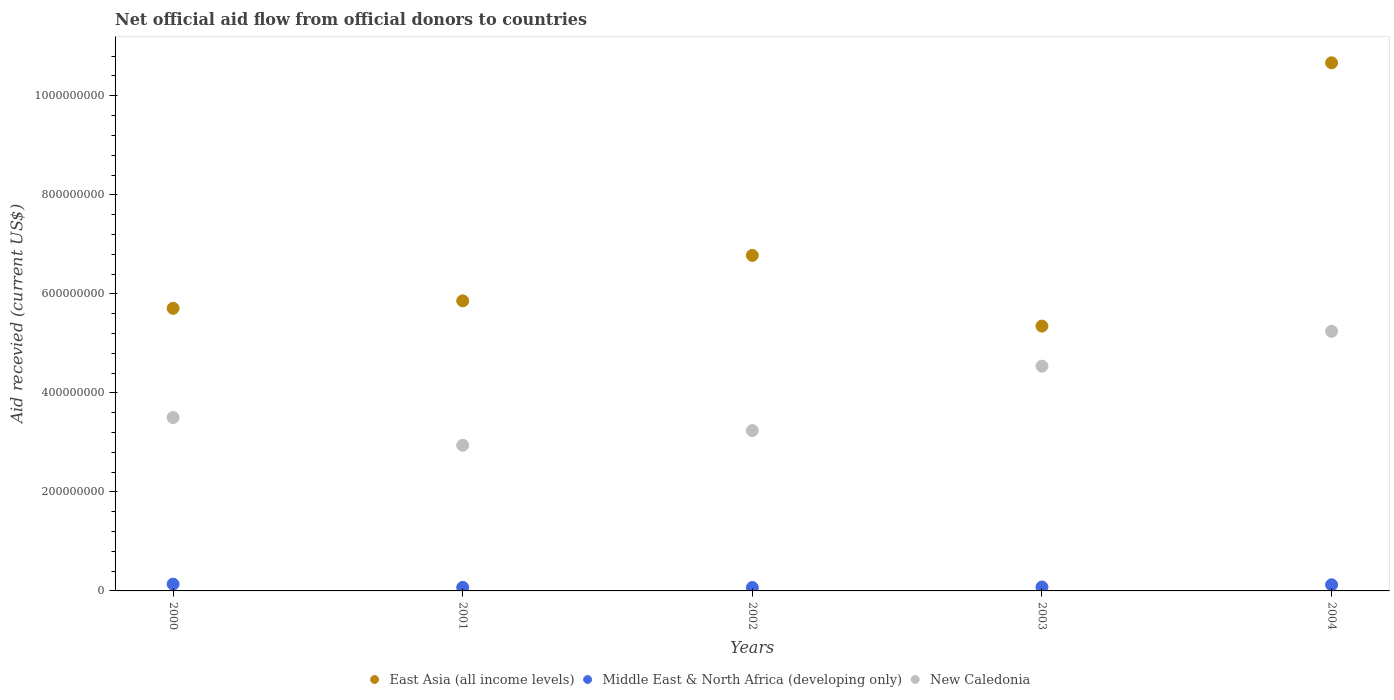How many different coloured dotlines are there?
Offer a terse response. 3. What is the total aid received in New Caledonia in 2004?
Ensure brevity in your answer.  5.24e+08. Across all years, what is the maximum total aid received in Middle East & North Africa (developing only)?
Make the answer very short. 1.38e+07. Across all years, what is the minimum total aid received in New Caledonia?
Your response must be concise. 2.94e+08. In which year was the total aid received in New Caledonia minimum?
Provide a succinct answer. 2001. What is the total total aid received in Middle East & North Africa (developing only) in the graph?
Keep it short and to the point. 4.82e+07. What is the difference between the total aid received in East Asia (all income levels) in 2000 and that in 2004?
Your answer should be compact. -4.96e+08. What is the difference between the total aid received in New Caledonia in 2004 and the total aid received in East Asia (all income levels) in 2003?
Offer a very short reply. -1.05e+07. What is the average total aid received in Middle East & North Africa (developing only) per year?
Your response must be concise. 9.63e+06. In the year 2004, what is the difference between the total aid received in New Caledonia and total aid received in Middle East & North Africa (developing only)?
Your answer should be compact. 5.12e+08. What is the ratio of the total aid received in Middle East & North Africa (developing only) in 2000 to that in 2004?
Your answer should be compact. 1.11. Is the difference between the total aid received in New Caledonia in 2000 and 2002 greater than the difference between the total aid received in Middle East & North Africa (developing only) in 2000 and 2002?
Ensure brevity in your answer.  Yes. What is the difference between the highest and the second highest total aid received in East Asia (all income levels)?
Give a very brief answer. 3.89e+08. What is the difference between the highest and the lowest total aid received in New Caledonia?
Make the answer very short. 2.30e+08. In how many years, is the total aid received in Middle East & North Africa (developing only) greater than the average total aid received in Middle East & North Africa (developing only) taken over all years?
Your answer should be very brief. 2. Are the values on the major ticks of Y-axis written in scientific E-notation?
Keep it short and to the point. No. Does the graph contain grids?
Your answer should be very brief. No. Where does the legend appear in the graph?
Your answer should be very brief. Bottom center. How many legend labels are there?
Your response must be concise. 3. What is the title of the graph?
Ensure brevity in your answer.  Net official aid flow from official donors to countries. What is the label or title of the Y-axis?
Your answer should be very brief. Aid recevied (current US$). What is the Aid recevied (current US$) of East Asia (all income levels) in 2000?
Provide a succinct answer. 5.71e+08. What is the Aid recevied (current US$) in Middle East & North Africa (developing only) in 2000?
Provide a short and direct response. 1.38e+07. What is the Aid recevied (current US$) in New Caledonia in 2000?
Offer a terse response. 3.50e+08. What is the Aid recevied (current US$) in East Asia (all income levels) in 2001?
Provide a succinct answer. 5.86e+08. What is the Aid recevied (current US$) in Middle East & North Africa (developing only) in 2001?
Offer a terse response. 7.14e+06. What is the Aid recevied (current US$) of New Caledonia in 2001?
Your response must be concise. 2.94e+08. What is the Aid recevied (current US$) of East Asia (all income levels) in 2002?
Make the answer very short. 6.78e+08. What is the Aid recevied (current US$) of Middle East & North Africa (developing only) in 2002?
Offer a very short reply. 6.88e+06. What is the Aid recevied (current US$) in New Caledonia in 2002?
Offer a very short reply. 3.24e+08. What is the Aid recevied (current US$) of East Asia (all income levels) in 2003?
Give a very brief answer. 5.35e+08. What is the Aid recevied (current US$) in Middle East & North Africa (developing only) in 2003?
Keep it short and to the point. 7.95e+06. What is the Aid recevied (current US$) in New Caledonia in 2003?
Provide a succinct answer. 4.54e+08. What is the Aid recevied (current US$) in East Asia (all income levels) in 2004?
Offer a very short reply. 1.07e+09. What is the Aid recevied (current US$) in Middle East & North Africa (developing only) in 2004?
Keep it short and to the point. 1.24e+07. What is the Aid recevied (current US$) in New Caledonia in 2004?
Offer a terse response. 5.24e+08. Across all years, what is the maximum Aid recevied (current US$) in East Asia (all income levels)?
Your response must be concise. 1.07e+09. Across all years, what is the maximum Aid recevied (current US$) of Middle East & North Africa (developing only)?
Your answer should be compact. 1.38e+07. Across all years, what is the maximum Aid recevied (current US$) in New Caledonia?
Provide a succinct answer. 5.24e+08. Across all years, what is the minimum Aid recevied (current US$) in East Asia (all income levels)?
Offer a very short reply. 5.35e+08. Across all years, what is the minimum Aid recevied (current US$) of Middle East & North Africa (developing only)?
Your answer should be compact. 6.88e+06. Across all years, what is the minimum Aid recevied (current US$) in New Caledonia?
Your response must be concise. 2.94e+08. What is the total Aid recevied (current US$) of East Asia (all income levels) in the graph?
Keep it short and to the point. 3.44e+09. What is the total Aid recevied (current US$) in Middle East & North Africa (developing only) in the graph?
Your response must be concise. 4.82e+07. What is the total Aid recevied (current US$) in New Caledonia in the graph?
Offer a terse response. 1.95e+09. What is the difference between the Aid recevied (current US$) of East Asia (all income levels) in 2000 and that in 2001?
Offer a terse response. -1.50e+07. What is the difference between the Aid recevied (current US$) in Middle East & North Africa (developing only) in 2000 and that in 2001?
Keep it short and to the point. 6.61e+06. What is the difference between the Aid recevied (current US$) of New Caledonia in 2000 and that in 2001?
Your answer should be very brief. 5.60e+07. What is the difference between the Aid recevied (current US$) of East Asia (all income levels) in 2000 and that in 2002?
Offer a terse response. -1.07e+08. What is the difference between the Aid recevied (current US$) in Middle East & North Africa (developing only) in 2000 and that in 2002?
Provide a succinct answer. 6.87e+06. What is the difference between the Aid recevied (current US$) in New Caledonia in 2000 and that in 2002?
Your answer should be very brief. 2.63e+07. What is the difference between the Aid recevied (current US$) of East Asia (all income levels) in 2000 and that in 2003?
Make the answer very short. 3.59e+07. What is the difference between the Aid recevied (current US$) in Middle East & North Africa (developing only) in 2000 and that in 2003?
Provide a short and direct response. 5.80e+06. What is the difference between the Aid recevied (current US$) of New Caledonia in 2000 and that in 2003?
Your response must be concise. -1.04e+08. What is the difference between the Aid recevied (current US$) in East Asia (all income levels) in 2000 and that in 2004?
Provide a succinct answer. -4.96e+08. What is the difference between the Aid recevied (current US$) in Middle East & North Africa (developing only) in 2000 and that in 2004?
Make the answer very short. 1.32e+06. What is the difference between the Aid recevied (current US$) in New Caledonia in 2000 and that in 2004?
Your response must be concise. -1.74e+08. What is the difference between the Aid recevied (current US$) of East Asia (all income levels) in 2001 and that in 2002?
Ensure brevity in your answer.  -9.18e+07. What is the difference between the Aid recevied (current US$) in New Caledonia in 2001 and that in 2002?
Offer a very short reply. -2.97e+07. What is the difference between the Aid recevied (current US$) in East Asia (all income levels) in 2001 and that in 2003?
Offer a very short reply. 5.10e+07. What is the difference between the Aid recevied (current US$) of Middle East & North Africa (developing only) in 2001 and that in 2003?
Your answer should be compact. -8.10e+05. What is the difference between the Aid recevied (current US$) in New Caledonia in 2001 and that in 2003?
Give a very brief answer. -1.60e+08. What is the difference between the Aid recevied (current US$) in East Asia (all income levels) in 2001 and that in 2004?
Your answer should be very brief. -4.81e+08. What is the difference between the Aid recevied (current US$) in Middle East & North Africa (developing only) in 2001 and that in 2004?
Ensure brevity in your answer.  -5.29e+06. What is the difference between the Aid recevied (current US$) of New Caledonia in 2001 and that in 2004?
Make the answer very short. -2.30e+08. What is the difference between the Aid recevied (current US$) of East Asia (all income levels) in 2002 and that in 2003?
Provide a short and direct response. 1.43e+08. What is the difference between the Aid recevied (current US$) of Middle East & North Africa (developing only) in 2002 and that in 2003?
Provide a short and direct response. -1.07e+06. What is the difference between the Aid recevied (current US$) of New Caledonia in 2002 and that in 2003?
Offer a terse response. -1.30e+08. What is the difference between the Aid recevied (current US$) of East Asia (all income levels) in 2002 and that in 2004?
Give a very brief answer. -3.89e+08. What is the difference between the Aid recevied (current US$) of Middle East & North Africa (developing only) in 2002 and that in 2004?
Keep it short and to the point. -5.55e+06. What is the difference between the Aid recevied (current US$) of New Caledonia in 2002 and that in 2004?
Make the answer very short. -2.01e+08. What is the difference between the Aid recevied (current US$) in East Asia (all income levels) in 2003 and that in 2004?
Provide a succinct answer. -5.32e+08. What is the difference between the Aid recevied (current US$) of Middle East & North Africa (developing only) in 2003 and that in 2004?
Give a very brief answer. -4.48e+06. What is the difference between the Aid recevied (current US$) in New Caledonia in 2003 and that in 2004?
Give a very brief answer. -7.04e+07. What is the difference between the Aid recevied (current US$) in East Asia (all income levels) in 2000 and the Aid recevied (current US$) in Middle East & North Africa (developing only) in 2001?
Keep it short and to the point. 5.64e+08. What is the difference between the Aid recevied (current US$) in East Asia (all income levels) in 2000 and the Aid recevied (current US$) in New Caledonia in 2001?
Make the answer very short. 2.77e+08. What is the difference between the Aid recevied (current US$) of Middle East & North Africa (developing only) in 2000 and the Aid recevied (current US$) of New Caledonia in 2001?
Make the answer very short. -2.80e+08. What is the difference between the Aid recevied (current US$) in East Asia (all income levels) in 2000 and the Aid recevied (current US$) in Middle East & North Africa (developing only) in 2002?
Make the answer very short. 5.64e+08. What is the difference between the Aid recevied (current US$) in East Asia (all income levels) in 2000 and the Aid recevied (current US$) in New Caledonia in 2002?
Offer a terse response. 2.47e+08. What is the difference between the Aid recevied (current US$) of Middle East & North Africa (developing only) in 2000 and the Aid recevied (current US$) of New Caledonia in 2002?
Provide a short and direct response. -3.10e+08. What is the difference between the Aid recevied (current US$) of East Asia (all income levels) in 2000 and the Aid recevied (current US$) of Middle East & North Africa (developing only) in 2003?
Ensure brevity in your answer.  5.63e+08. What is the difference between the Aid recevied (current US$) in East Asia (all income levels) in 2000 and the Aid recevied (current US$) in New Caledonia in 2003?
Keep it short and to the point. 1.17e+08. What is the difference between the Aid recevied (current US$) in Middle East & North Africa (developing only) in 2000 and the Aid recevied (current US$) in New Caledonia in 2003?
Keep it short and to the point. -4.40e+08. What is the difference between the Aid recevied (current US$) of East Asia (all income levels) in 2000 and the Aid recevied (current US$) of Middle East & North Africa (developing only) in 2004?
Ensure brevity in your answer.  5.58e+08. What is the difference between the Aid recevied (current US$) in East Asia (all income levels) in 2000 and the Aid recevied (current US$) in New Caledonia in 2004?
Your answer should be compact. 4.64e+07. What is the difference between the Aid recevied (current US$) of Middle East & North Africa (developing only) in 2000 and the Aid recevied (current US$) of New Caledonia in 2004?
Provide a succinct answer. -5.11e+08. What is the difference between the Aid recevied (current US$) in East Asia (all income levels) in 2001 and the Aid recevied (current US$) in Middle East & North Africa (developing only) in 2002?
Your answer should be compact. 5.79e+08. What is the difference between the Aid recevied (current US$) in East Asia (all income levels) in 2001 and the Aid recevied (current US$) in New Caledonia in 2002?
Keep it short and to the point. 2.62e+08. What is the difference between the Aid recevied (current US$) in Middle East & North Africa (developing only) in 2001 and the Aid recevied (current US$) in New Caledonia in 2002?
Keep it short and to the point. -3.17e+08. What is the difference between the Aid recevied (current US$) in East Asia (all income levels) in 2001 and the Aid recevied (current US$) in Middle East & North Africa (developing only) in 2003?
Your answer should be compact. 5.78e+08. What is the difference between the Aid recevied (current US$) in East Asia (all income levels) in 2001 and the Aid recevied (current US$) in New Caledonia in 2003?
Your answer should be compact. 1.32e+08. What is the difference between the Aid recevied (current US$) in Middle East & North Africa (developing only) in 2001 and the Aid recevied (current US$) in New Caledonia in 2003?
Provide a succinct answer. -4.47e+08. What is the difference between the Aid recevied (current US$) of East Asia (all income levels) in 2001 and the Aid recevied (current US$) of Middle East & North Africa (developing only) in 2004?
Make the answer very short. 5.73e+08. What is the difference between the Aid recevied (current US$) of East Asia (all income levels) in 2001 and the Aid recevied (current US$) of New Caledonia in 2004?
Offer a terse response. 6.15e+07. What is the difference between the Aid recevied (current US$) of Middle East & North Africa (developing only) in 2001 and the Aid recevied (current US$) of New Caledonia in 2004?
Your answer should be very brief. -5.17e+08. What is the difference between the Aid recevied (current US$) of East Asia (all income levels) in 2002 and the Aid recevied (current US$) of Middle East & North Africa (developing only) in 2003?
Give a very brief answer. 6.70e+08. What is the difference between the Aid recevied (current US$) in East Asia (all income levels) in 2002 and the Aid recevied (current US$) in New Caledonia in 2003?
Keep it short and to the point. 2.24e+08. What is the difference between the Aid recevied (current US$) in Middle East & North Africa (developing only) in 2002 and the Aid recevied (current US$) in New Caledonia in 2003?
Keep it short and to the point. -4.47e+08. What is the difference between the Aid recevied (current US$) in East Asia (all income levels) in 2002 and the Aid recevied (current US$) in Middle East & North Africa (developing only) in 2004?
Your answer should be very brief. 6.65e+08. What is the difference between the Aid recevied (current US$) of East Asia (all income levels) in 2002 and the Aid recevied (current US$) of New Caledonia in 2004?
Offer a terse response. 1.53e+08. What is the difference between the Aid recevied (current US$) of Middle East & North Africa (developing only) in 2002 and the Aid recevied (current US$) of New Caledonia in 2004?
Provide a short and direct response. -5.17e+08. What is the difference between the Aid recevied (current US$) in East Asia (all income levels) in 2003 and the Aid recevied (current US$) in Middle East & North Africa (developing only) in 2004?
Offer a very short reply. 5.22e+08. What is the difference between the Aid recevied (current US$) of East Asia (all income levels) in 2003 and the Aid recevied (current US$) of New Caledonia in 2004?
Provide a succinct answer. 1.05e+07. What is the difference between the Aid recevied (current US$) of Middle East & North Africa (developing only) in 2003 and the Aid recevied (current US$) of New Caledonia in 2004?
Provide a short and direct response. -5.16e+08. What is the average Aid recevied (current US$) in East Asia (all income levels) per year?
Offer a very short reply. 6.87e+08. What is the average Aid recevied (current US$) in Middle East & North Africa (developing only) per year?
Your answer should be very brief. 9.63e+06. What is the average Aid recevied (current US$) of New Caledonia per year?
Provide a succinct answer. 3.89e+08. In the year 2000, what is the difference between the Aid recevied (current US$) in East Asia (all income levels) and Aid recevied (current US$) in Middle East & North Africa (developing only)?
Keep it short and to the point. 5.57e+08. In the year 2000, what is the difference between the Aid recevied (current US$) of East Asia (all income levels) and Aid recevied (current US$) of New Caledonia?
Your response must be concise. 2.21e+08. In the year 2000, what is the difference between the Aid recevied (current US$) in Middle East & North Africa (developing only) and Aid recevied (current US$) in New Caledonia?
Offer a terse response. -3.36e+08. In the year 2001, what is the difference between the Aid recevied (current US$) in East Asia (all income levels) and Aid recevied (current US$) in Middle East & North Africa (developing only)?
Ensure brevity in your answer.  5.79e+08. In the year 2001, what is the difference between the Aid recevied (current US$) of East Asia (all income levels) and Aid recevied (current US$) of New Caledonia?
Provide a short and direct response. 2.92e+08. In the year 2001, what is the difference between the Aid recevied (current US$) in Middle East & North Africa (developing only) and Aid recevied (current US$) in New Caledonia?
Ensure brevity in your answer.  -2.87e+08. In the year 2002, what is the difference between the Aid recevied (current US$) of East Asia (all income levels) and Aid recevied (current US$) of Middle East & North Africa (developing only)?
Offer a terse response. 6.71e+08. In the year 2002, what is the difference between the Aid recevied (current US$) of East Asia (all income levels) and Aid recevied (current US$) of New Caledonia?
Your response must be concise. 3.54e+08. In the year 2002, what is the difference between the Aid recevied (current US$) of Middle East & North Africa (developing only) and Aid recevied (current US$) of New Caledonia?
Make the answer very short. -3.17e+08. In the year 2003, what is the difference between the Aid recevied (current US$) of East Asia (all income levels) and Aid recevied (current US$) of Middle East & North Africa (developing only)?
Give a very brief answer. 5.27e+08. In the year 2003, what is the difference between the Aid recevied (current US$) in East Asia (all income levels) and Aid recevied (current US$) in New Caledonia?
Your answer should be compact. 8.10e+07. In the year 2003, what is the difference between the Aid recevied (current US$) in Middle East & North Africa (developing only) and Aid recevied (current US$) in New Caledonia?
Offer a very short reply. -4.46e+08. In the year 2004, what is the difference between the Aid recevied (current US$) in East Asia (all income levels) and Aid recevied (current US$) in Middle East & North Africa (developing only)?
Provide a succinct answer. 1.05e+09. In the year 2004, what is the difference between the Aid recevied (current US$) in East Asia (all income levels) and Aid recevied (current US$) in New Caledonia?
Make the answer very short. 5.42e+08. In the year 2004, what is the difference between the Aid recevied (current US$) in Middle East & North Africa (developing only) and Aid recevied (current US$) in New Caledonia?
Your answer should be very brief. -5.12e+08. What is the ratio of the Aid recevied (current US$) in East Asia (all income levels) in 2000 to that in 2001?
Make the answer very short. 0.97. What is the ratio of the Aid recevied (current US$) of Middle East & North Africa (developing only) in 2000 to that in 2001?
Give a very brief answer. 1.93. What is the ratio of the Aid recevied (current US$) of New Caledonia in 2000 to that in 2001?
Offer a very short reply. 1.19. What is the ratio of the Aid recevied (current US$) in East Asia (all income levels) in 2000 to that in 2002?
Give a very brief answer. 0.84. What is the ratio of the Aid recevied (current US$) of Middle East & North Africa (developing only) in 2000 to that in 2002?
Provide a succinct answer. 2. What is the ratio of the Aid recevied (current US$) of New Caledonia in 2000 to that in 2002?
Make the answer very short. 1.08. What is the ratio of the Aid recevied (current US$) of East Asia (all income levels) in 2000 to that in 2003?
Your answer should be compact. 1.07. What is the ratio of the Aid recevied (current US$) in Middle East & North Africa (developing only) in 2000 to that in 2003?
Ensure brevity in your answer.  1.73. What is the ratio of the Aid recevied (current US$) in New Caledonia in 2000 to that in 2003?
Provide a short and direct response. 0.77. What is the ratio of the Aid recevied (current US$) in East Asia (all income levels) in 2000 to that in 2004?
Keep it short and to the point. 0.54. What is the ratio of the Aid recevied (current US$) of Middle East & North Africa (developing only) in 2000 to that in 2004?
Offer a very short reply. 1.11. What is the ratio of the Aid recevied (current US$) in New Caledonia in 2000 to that in 2004?
Offer a very short reply. 0.67. What is the ratio of the Aid recevied (current US$) of East Asia (all income levels) in 2001 to that in 2002?
Your response must be concise. 0.86. What is the ratio of the Aid recevied (current US$) in Middle East & North Africa (developing only) in 2001 to that in 2002?
Your answer should be compact. 1.04. What is the ratio of the Aid recevied (current US$) of New Caledonia in 2001 to that in 2002?
Offer a terse response. 0.91. What is the ratio of the Aid recevied (current US$) of East Asia (all income levels) in 2001 to that in 2003?
Ensure brevity in your answer.  1.1. What is the ratio of the Aid recevied (current US$) in Middle East & North Africa (developing only) in 2001 to that in 2003?
Provide a short and direct response. 0.9. What is the ratio of the Aid recevied (current US$) in New Caledonia in 2001 to that in 2003?
Offer a terse response. 0.65. What is the ratio of the Aid recevied (current US$) of East Asia (all income levels) in 2001 to that in 2004?
Make the answer very short. 0.55. What is the ratio of the Aid recevied (current US$) of Middle East & North Africa (developing only) in 2001 to that in 2004?
Offer a terse response. 0.57. What is the ratio of the Aid recevied (current US$) of New Caledonia in 2001 to that in 2004?
Your answer should be compact. 0.56. What is the ratio of the Aid recevied (current US$) in East Asia (all income levels) in 2002 to that in 2003?
Keep it short and to the point. 1.27. What is the ratio of the Aid recevied (current US$) in Middle East & North Africa (developing only) in 2002 to that in 2003?
Offer a terse response. 0.87. What is the ratio of the Aid recevied (current US$) in New Caledonia in 2002 to that in 2003?
Provide a succinct answer. 0.71. What is the ratio of the Aid recevied (current US$) in East Asia (all income levels) in 2002 to that in 2004?
Keep it short and to the point. 0.64. What is the ratio of the Aid recevied (current US$) in Middle East & North Africa (developing only) in 2002 to that in 2004?
Provide a short and direct response. 0.55. What is the ratio of the Aid recevied (current US$) in New Caledonia in 2002 to that in 2004?
Keep it short and to the point. 0.62. What is the ratio of the Aid recevied (current US$) in East Asia (all income levels) in 2003 to that in 2004?
Give a very brief answer. 0.5. What is the ratio of the Aid recevied (current US$) in Middle East & North Africa (developing only) in 2003 to that in 2004?
Your answer should be compact. 0.64. What is the ratio of the Aid recevied (current US$) of New Caledonia in 2003 to that in 2004?
Offer a terse response. 0.87. What is the difference between the highest and the second highest Aid recevied (current US$) of East Asia (all income levels)?
Offer a very short reply. 3.89e+08. What is the difference between the highest and the second highest Aid recevied (current US$) in Middle East & North Africa (developing only)?
Make the answer very short. 1.32e+06. What is the difference between the highest and the second highest Aid recevied (current US$) of New Caledonia?
Keep it short and to the point. 7.04e+07. What is the difference between the highest and the lowest Aid recevied (current US$) of East Asia (all income levels)?
Your answer should be very brief. 5.32e+08. What is the difference between the highest and the lowest Aid recevied (current US$) in Middle East & North Africa (developing only)?
Ensure brevity in your answer.  6.87e+06. What is the difference between the highest and the lowest Aid recevied (current US$) of New Caledonia?
Your response must be concise. 2.30e+08. 